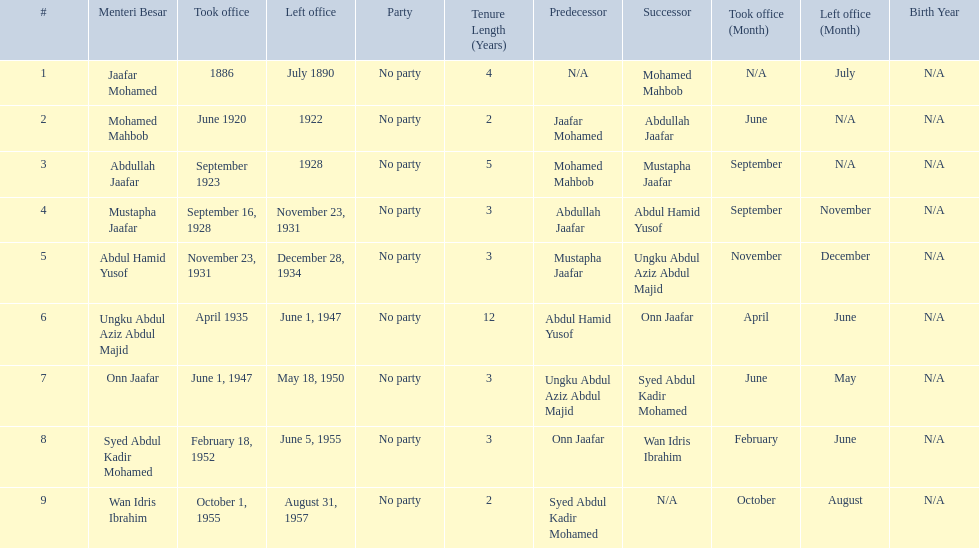What are all the people that were menteri besar of johor? Jaafar Mohamed, Mohamed Mahbob, Abdullah Jaafar, Mustapha Jaafar, Abdul Hamid Yusof, Ungku Abdul Aziz Abdul Majid, Onn Jaafar, Syed Abdul Kadir Mohamed, Wan Idris Ibrahim. Who ruled the longest? Ungku Abdul Aziz Abdul Majid. 